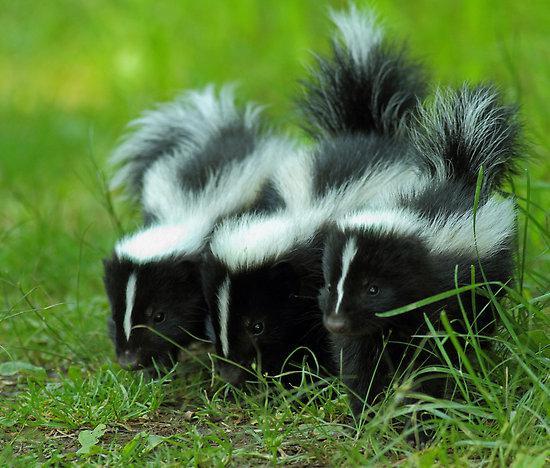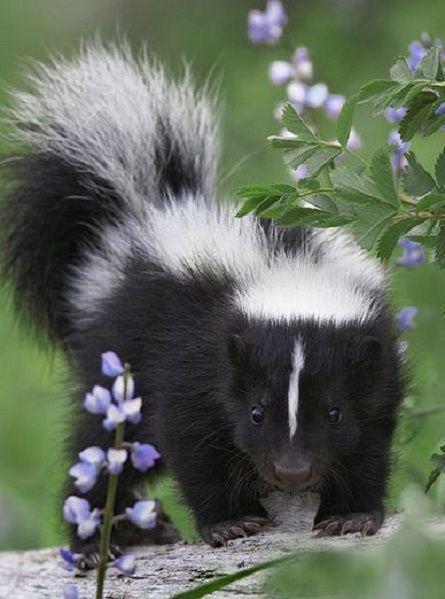The first image is the image on the left, the second image is the image on the right. Considering the images on both sides, is "Left and right images do not contain the same number of skunks, and the left image contains at least one leftward angled skunk with an upright tail." valid? Answer yes or no. Yes. The first image is the image on the left, the second image is the image on the right. For the images displayed, is the sentence "Two skunks are visible." factually correct? Answer yes or no. No. 